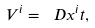Convert formula to latex. <formula><loc_0><loc_0><loc_500><loc_500>V ^ { i } = \ D { x ^ { i } } { t } ,</formula> 